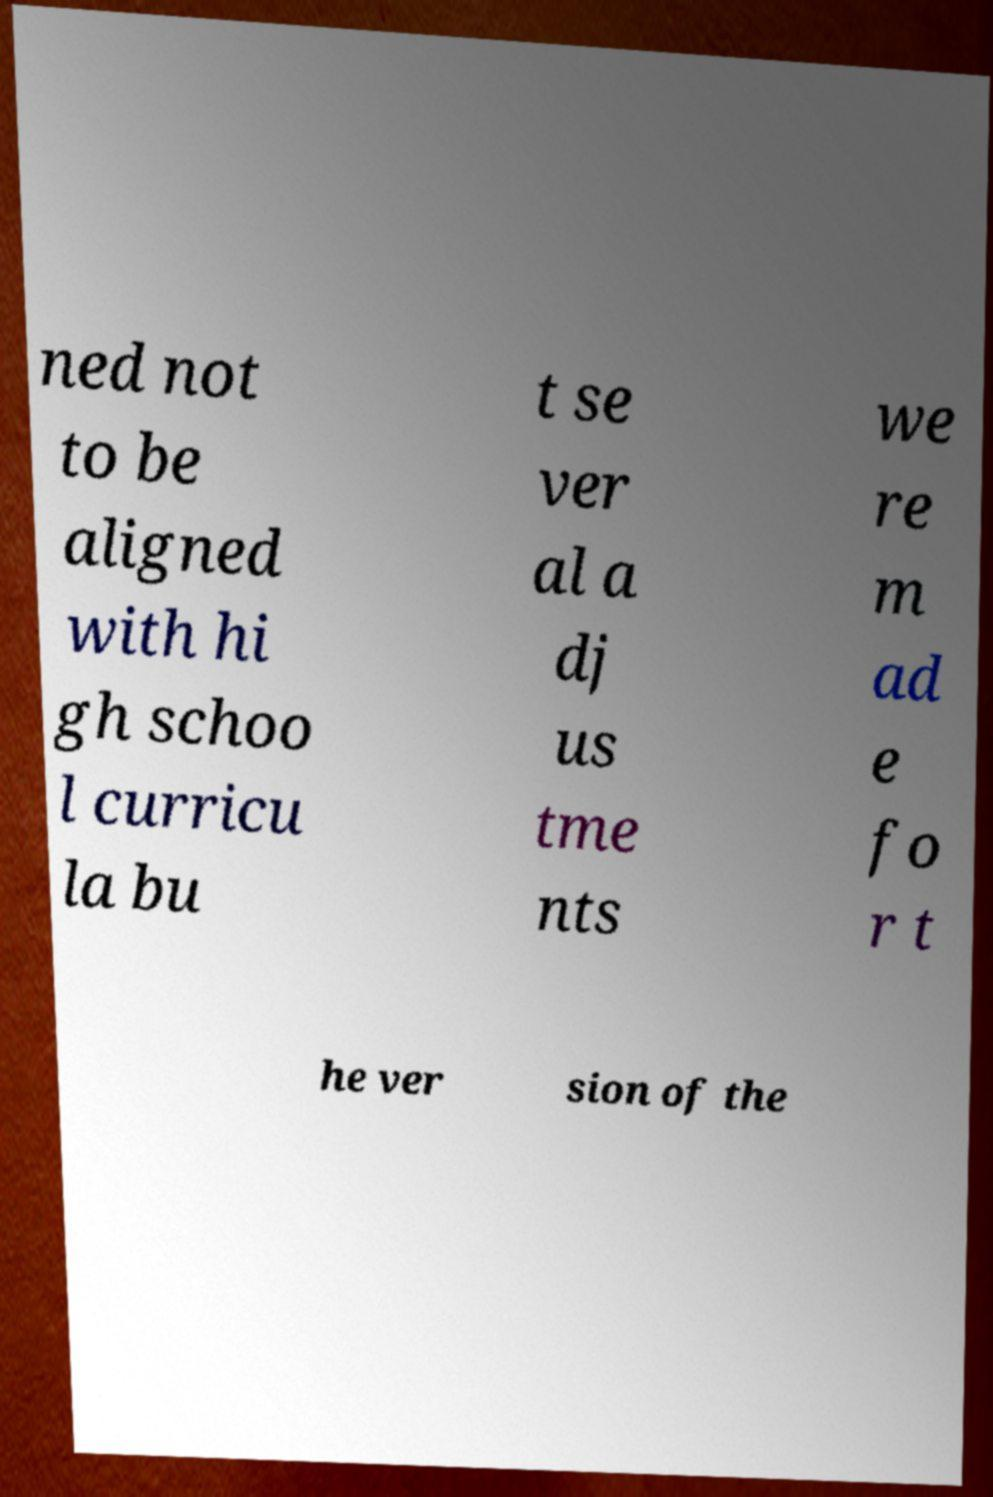Please identify and transcribe the text found in this image. ned not to be aligned with hi gh schoo l curricu la bu t se ver al a dj us tme nts we re m ad e fo r t he ver sion of the 